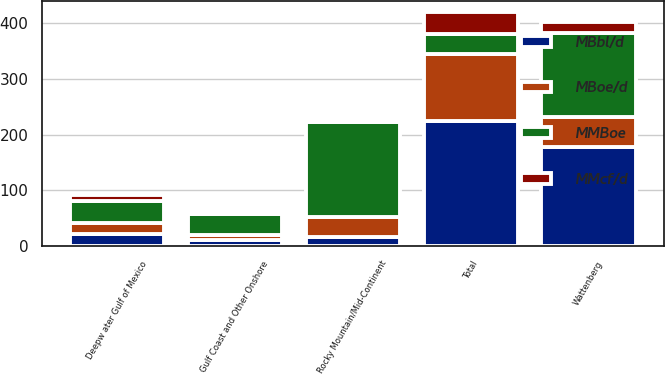Convert chart. <chart><loc_0><loc_0><loc_500><loc_500><stacked_bar_chart><ecel><fcel>Wattenberg<fcel>Rocky Mountain/Mid-Continent<fcel>Deepw ater Gulf of Mexico<fcel>Gulf Coast and Other Onshore<fcel>Total<nl><fcel>MMcf/d<fcel>19<fcel>5<fcel>11<fcel>4<fcel>39<nl><fcel>MMBoe<fcel>151<fcel>171<fcel>40<fcel>38<fcel>36<nl><fcel>MBoe/d<fcel>54<fcel>36<fcel>19<fcel>10<fcel>119<nl><fcel>MBbl/d<fcel>177<fcel>16<fcel>22<fcel>10<fcel>225<nl></chart> 